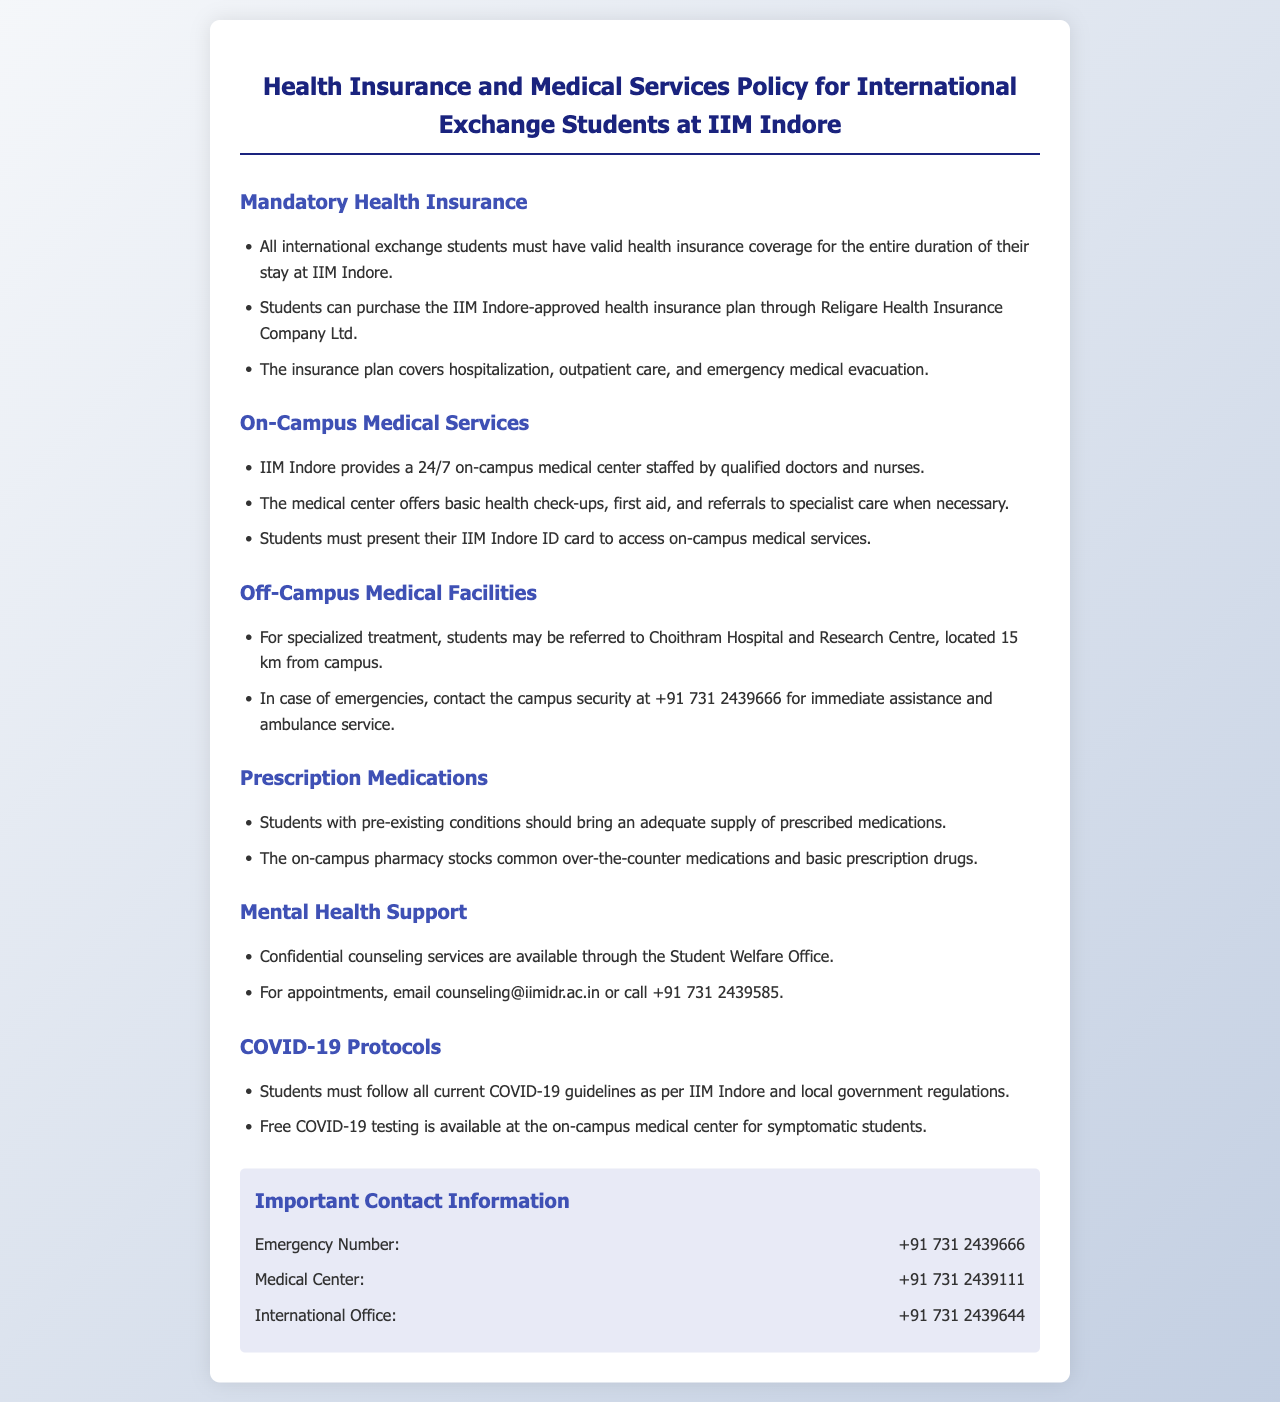what must all international exchange students have? The document states that all international exchange students must have valid health insurance coverage for the entire duration of their stay at IIM Indore.
Answer: valid health insurance coverage who provides on-campus medical services? The document mentions that IIM Indore provides a 24/7 on-campus medical center staffed by qualified doctors and nurses.
Answer: IIM Indore how far is the Choithram Hospital and Research Centre from the campus? According to the document, Choithram Hospital and Research Centre is located 15 km from the campus.
Answer: 15 km what is required to access on-campus medical services? The document specifies that students must present their IIM Indore ID card to access on-campus medical services.
Answer: IIM Indore ID card how can students make appointments for mental health support? The document states that students can email counseling@iimidr.ac.in or call +91 731 2439585 for mental health support appointments.
Answer: email or call what type of support is available for mental health? The document indicates that confidential counseling services are available through the Student Welfare Office.
Answer: counseling services what is the emergency contact number provided in the document? The document provides the emergency contact number as +91 731 2439666.
Answer: +91 731 2439666 what protocols must students follow regarding COVID-19? The document states that students must follow all current COVID-19 guidelines as per IIM Indore and local government regulations.
Answer: current COVID-19 guidelines what services does the on-campus pharmacy offer? The document states that the on-campus pharmacy stocks common over-the-counter medications and basic prescription drugs.
Answer: over-the-counter and prescription drugs 